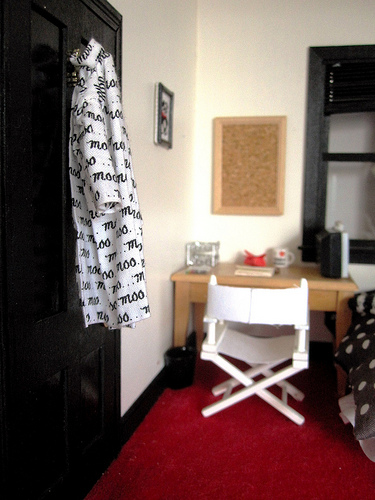<image>
Is the shirt on the wall? No. The shirt is not positioned on the wall. They may be near each other, but the shirt is not supported by or resting on top of the wall. 